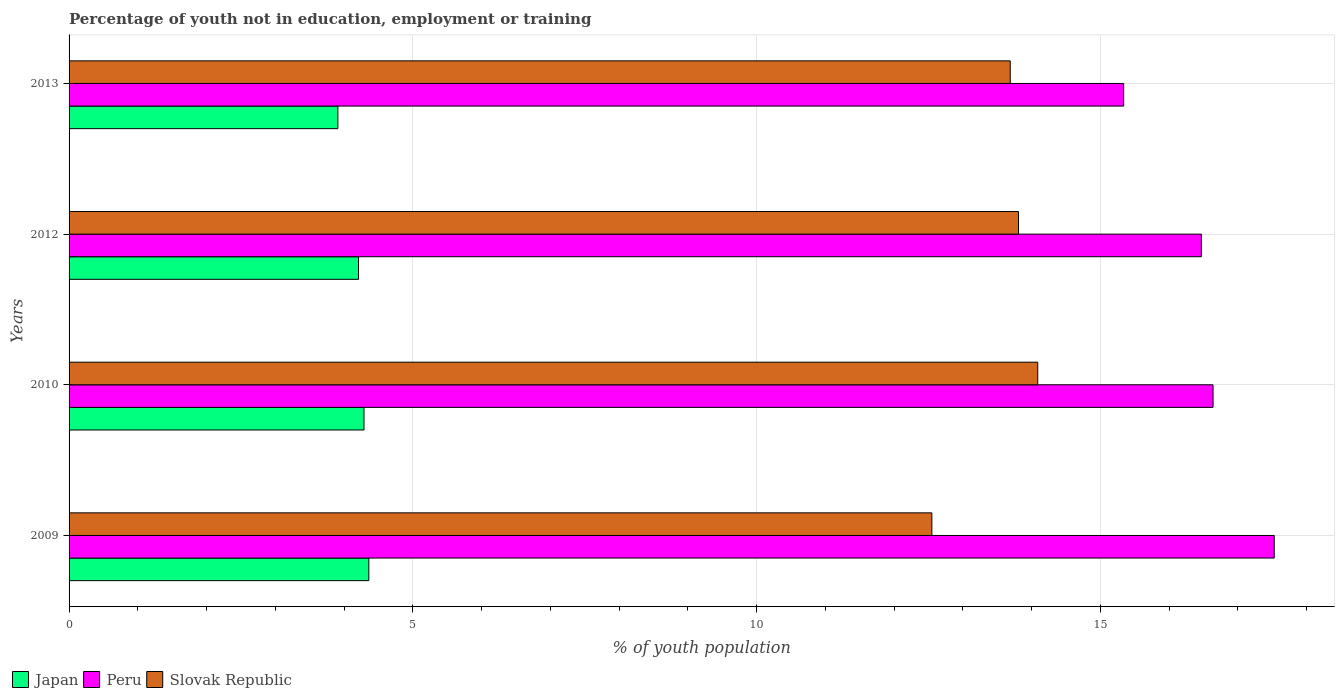How many different coloured bars are there?
Your response must be concise. 3. How many groups of bars are there?
Ensure brevity in your answer.  4. How many bars are there on the 3rd tick from the top?
Provide a short and direct response. 3. How many bars are there on the 4th tick from the bottom?
Provide a short and direct response. 3. What is the label of the 4th group of bars from the top?
Provide a short and direct response. 2009. What is the percentage of unemployed youth population in in Peru in 2010?
Ensure brevity in your answer.  16.64. Across all years, what is the maximum percentage of unemployed youth population in in Japan?
Ensure brevity in your answer.  4.36. Across all years, what is the minimum percentage of unemployed youth population in in Peru?
Your answer should be compact. 15.34. In which year was the percentage of unemployed youth population in in Japan maximum?
Make the answer very short. 2009. What is the total percentage of unemployed youth population in in Japan in the graph?
Offer a terse response. 16.77. What is the difference between the percentage of unemployed youth population in in Japan in 2010 and that in 2012?
Your response must be concise. 0.08. What is the difference between the percentage of unemployed youth population in in Japan in 2010 and the percentage of unemployed youth population in in Slovak Republic in 2012?
Your answer should be very brief. -9.52. What is the average percentage of unemployed youth population in in Peru per year?
Keep it short and to the point. 16.49. In the year 2009, what is the difference between the percentage of unemployed youth population in in Peru and percentage of unemployed youth population in in Slovak Republic?
Ensure brevity in your answer.  4.98. In how many years, is the percentage of unemployed youth population in in Slovak Republic greater than 3 %?
Provide a short and direct response. 4. What is the ratio of the percentage of unemployed youth population in in Japan in 2009 to that in 2010?
Provide a succinct answer. 1.02. Is the percentage of unemployed youth population in in Slovak Republic in 2009 less than that in 2013?
Your response must be concise. Yes. Is the difference between the percentage of unemployed youth population in in Peru in 2009 and 2012 greater than the difference between the percentage of unemployed youth population in in Slovak Republic in 2009 and 2012?
Give a very brief answer. Yes. What is the difference between the highest and the second highest percentage of unemployed youth population in in Slovak Republic?
Keep it short and to the point. 0.28. What is the difference between the highest and the lowest percentage of unemployed youth population in in Peru?
Your answer should be very brief. 2.19. What does the 1st bar from the top in 2010 represents?
Your answer should be very brief. Slovak Republic. What does the 1st bar from the bottom in 2009 represents?
Give a very brief answer. Japan. Is it the case that in every year, the sum of the percentage of unemployed youth population in in Japan and percentage of unemployed youth population in in Peru is greater than the percentage of unemployed youth population in in Slovak Republic?
Offer a terse response. Yes. Are all the bars in the graph horizontal?
Make the answer very short. Yes. How many years are there in the graph?
Your answer should be very brief. 4. Are the values on the major ticks of X-axis written in scientific E-notation?
Your response must be concise. No. Does the graph contain grids?
Give a very brief answer. Yes. What is the title of the graph?
Provide a short and direct response. Percentage of youth not in education, employment or training. What is the label or title of the X-axis?
Your response must be concise. % of youth population. What is the % of youth population in Japan in 2009?
Provide a short and direct response. 4.36. What is the % of youth population of Peru in 2009?
Provide a succinct answer. 17.53. What is the % of youth population of Slovak Republic in 2009?
Keep it short and to the point. 12.55. What is the % of youth population of Japan in 2010?
Your response must be concise. 4.29. What is the % of youth population of Peru in 2010?
Ensure brevity in your answer.  16.64. What is the % of youth population in Slovak Republic in 2010?
Your answer should be very brief. 14.09. What is the % of youth population of Japan in 2012?
Keep it short and to the point. 4.21. What is the % of youth population in Peru in 2012?
Provide a succinct answer. 16.47. What is the % of youth population of Slovak Republic in 2012?
Keep it short and to the point. 13.81. What is the % of youth population of Japan in 2013?
Provide a succinct answer. 3.91. What is the % of youth population of Peru in 2013?
Your response must be concise. 15.34. What is the % of youth population in Slovak Republic in 2013?
Keep it short and to the point. 13.69. Across all years, what is the maximum % of youth population of Japan?
Offer a very short reply. 4.36. Across all years, what is the maximum % of youth population in Peru?
Provide a succinct answer. 17.53. Across all years, what is the maximum % of youth population in Slovak Republic?
Your response must be concise. 14.09. Across all years, what is the minimum % of youth population in Japan?
Offer a terse response. 3.91. Across all years, what is the minimum % of youth population in Peru?
Provide a succinct answer. 15.34. Across all years, what is the minimum % of youth population of Slovak Republic?
Provide a short and direct response. 12.55. What is the total % of youth population in Japan in the graph?
Offer a terse response. 16.77. What is the total % of youth population of Peru in the graph?
Your response must be concise. 65.98. What is the total % of youth population of Slovak Republic in the graph?
Provide a short and direct response. 54.14. What is the difference between the % of youth population of Japan in 2009 and that in 2010?
Make the answer very short. 0.07. What is the difference between the % of youth population in Peru in 2009 and that in 2010?
Provide a short and direct response. 0.89. What is the difference between the % of youth population in Slovak Republic in 2009 and that in 2010?
Provide a succinct answer. -1.54. What is the difference between the % of youth population in Japan in 2009 and that in 2012?
Your answer should be very brief. 0.15. What is the difference between the % of youth population in Peru in 2009 and that in 2012?
Provide a succinct answer. 1.06. What is the difference between the % of youth population in Slovak Republic in 2009 and that in 2012?
Your response must be concise. -1.26. What is the difference between the % of youth population of Japan in 2009 and that in 2013?
Provide a succinct answer. 0.45. What is the difference between the % of youth population in Peru in 2009 and that in 2013?
Your response must be concise. 2.19. What is the difference between the % of youth population of Slovak Republic in 2009 and that in 2013?
Provide a succinct answer. -1.14. What is the difference between the % of youth population in Peru in 2010 and that in 2012?
Make the answer very short. 0.17. What is the difference between the % of youth population of Slovak Republic in 2010 and that in 2012?
Offer a terse response. 0.28. What is the difference between the % of youth population in Japan in 2010 and that in 2013?
Provide a succinct answer. 0.38. What is the difference between the % of youth population of Slovak Republic in 2010 and that in 2013?
Provide a succinct answer. 0.4. What is the difference between the % of youth population of Japan in 2012 and that in 2013?
Keep it short and to the point. 0.3. What is the difference between the % of youth population in Peru in 2012 and that in 2013?
Make the answer very short. 1.13. What is the difference between the % of youth population in Slovak Republic in 2012 and that in 2013?
Offer a terse response. 0.12. What is the difference between the % of youth population in Japan in 2009 and the % of youth population in Peru in 2010?
Provide a short and direct response. -12.28. What is the difference between the % of youth population of Japan in 2009 and the % of youth population of Slovak Republic in 2010?
Make the answer very short. -9.73. What is the difference between the % of youth population in Peru in 2009 and the % of youth population in Slovak Republic in 2010?
Your answer should be compact. 3.44. What is the difference between the % of youth population in Japan in 2009 and the % of youth population in Peru in 2012?
Offer a terse response. -12.11. What is the difference between the % of youth population in Japan in 2009 and the % of youth population in Slovak Republic in 2012?
Keep it short and to the point. -9.45. What is the difference between the % of youth population of Peru in 2009 and the % of youth population of Slovak Republic in 2012?
Keep it short and to the point. 3.72. What is the difference between the % of youth population of Japan in 2009 and the % of youth population of Peru in 2013?
Your response must be concise. -10.98. What is the difference between the % of youth population of Japan in 2009 and the % of youth population of Slovak Republic in 2013?
Your answer should be compact. -9.33. What is the difference between the % of youth population in Peru in 2009 and the % of youth population in Slovak Republic in 2013?
Offer a very short reply. 3.84. What is the difference between the % of youth population in Japan in 2010 and the % of youth population in Peru in 2012?
Ensure brevity in your answer.  -12.18. What is the difference between the % of youth population of Japan in 2010 and the % of youth population of Slovak Republic in 2012?
Offer a very short reply. -9.52. What is the difference between the % of youth population of Peru in 2010 and the % of youth population of Slovak Republic in 2012?
Provide a succinct answer. 2.83. What is the difference between the % of youth population of Japan in 2010 and the % of youth population of Peru in 2013?
Provide a succinct answer. -11.05. What is the difference between the % of youth population in Japan in 2010 and the % of youth population in Slovak Republic in 2013?
Provide a succinct answer. -9.4. What is the difference between the % of youth population in Peru in 2010 and the % of youth population in Slovak Republic in 2013?
Keep it short and to the point. 2.95. What is the difference between the % of youth population in Japan in 2012 and the % of youth population in Peru in 2013?
Offer a very short reply. -11.13. What is the difference between the % of youth population of Japan in 2012 and the % of youth population of Slovak Republic in 2013?
Your response must be concise. -9.48. What is the difference between the % of youth population of Peru in 2012 and the % of youth population of Slovak Republic in 2013?
Ensure brevity in your answer.  2.78. What is the average % of youth population of Japan per year?
Give a very brief answer. 4.19. What is the average % of youth population in Peru per year?
Provide a succinct answer. 16.5. What is the average % of youth population in Slovak Republic per year?
Your answer should be very brief. 13.54. In the year 2009, what is the difference between the % of youth population in Japan and % of youth population in Peru?
Offer a very short reply. -13.17. In the year 2009, what is the difference between the % of youth population in Japan and % of youth population in Slovak Republic?
Your response must be concise. -8.19. In the year 2009, what is the difference between the % of youth population of Peru and % of youth population of Slovak Republic?
Keep it short and to the point. 4.98. In the year 2010, what is the difference between the % of youth population in Japan and % of youth population in Peru?
Offer a very short reply. -12.35. In the year 2010, what is the difference between the % of youth population of Japan and % of youth population of Slovak Republic?
Your response must be concise. -9.8. In the year 2010, what is the difference between the % of youth population of Peru and % of youth population of Slovak Republic?
Make the answer very short. 2.55. In the year 2012, what is the difference between the % of youth population in Japan and % of youth population in Peru?
Ensure brevity in your answer.  -12.26. In the year 2012, what is the difference between the % of youth population in Peru and % of youth population in Slovak Republic?
Provide a short and direct response. 2.66. In the year 2013, what is the difference between the % of youth population of Japan and % of youth population of Peru?
Offer a very short reply. -11.43. In the year 2013, what is the difference between the % of youth population in Japan and % of youth population in Slovak Republic?
Ensure brevity in your answer.  -9.78. In the year 2013, what is the difference between the % of youth population of Peru and % of youth population of Slovak Republic?
Keep it short and to the point. 1.65. What is the ratio of the % of youth population of Japan in 2009 to that in 2010?
Your answer should be very brief. 1.02. What is the ratio of the % of youth population in Peru in 2009 to that in 2010?
Provide a succinct answer. 1.05. What is the ratio of the % of youth population of Slovak Republic in 2009 to that in 2010?
Your answer should be very brief. 0.89. What is the ratio of the % of youth population of Japan in 2009 to that in 2012?
Your answer should be compact. 1.04. What is the ratio of the % of youth population in Peru in 2009 to that in 2012?
Your answer should be compact. 1.06. What is the ratio of the % of youth population in Slovak Republic in 2009 to that in 2012?
Provide a short and direct response. 0.91. What is the ratio of the % of youth population of Japan in 2009 to that in 2013?
Provide a succinct answer. 1.12. What is the ratio of the % of youth population in Peru in 2009 to that in 2013?
Your answer should be compact. 1.14. What is the ratio of the % of youth population in Peru in 2010 to that in 2012?
Ensure brevity in your answer.  1.01. What is the ratio of the % of youth population in Slovak Republic in 2010 to that in 2012?
Ensure brevity in your answer.  1.02. What is the ratio of the % of youth population of Japan in 2010 to that in 2013?
Make the answer very short. 1.1. What is the ratio of the % of youth population of Peru in 2010 to that in 2013?
Offer a terse response. 1.08. What is the ratio of the % of youth population in Slovak Republic in 2010 to that in 2013?
Offer a terse response. 1.03. What is the ratio of the % of youth population of Japan in 2012 to that in 2013?
Provide a succinct answer. 1.08. What is the ratio of the % of youth population of Peru in 2012 to that in 2013?
Offer a very short reply. 1.07. What is the ratio of the % of youth population of Slovak Republic in 2012 to that in 2013?
Give a very brief answer. 1.01. What is the difference between the highest and the second highest % of youth population in Japan?
Keep it short and to the point. 0.07. What is the difference between the highest and the second highest % of youth population of Peru?
Ensure brevity in your answer.  0.89. What is the difference between the highest and the second highest % of youth population of Slovak Republic?
Offer a very short reply. 0.28. What is the difference between the highest and the lowest % of youth population in Japan?
Your response must be concise. 0.45. What is the difference between the highest and the lowest % of youth population of Peru?
Offer a terse response. 2.19. What is the difference between the highest and the lowest % of youth population of Slovak Republic?
Keep it short and to the point. 1.54. 